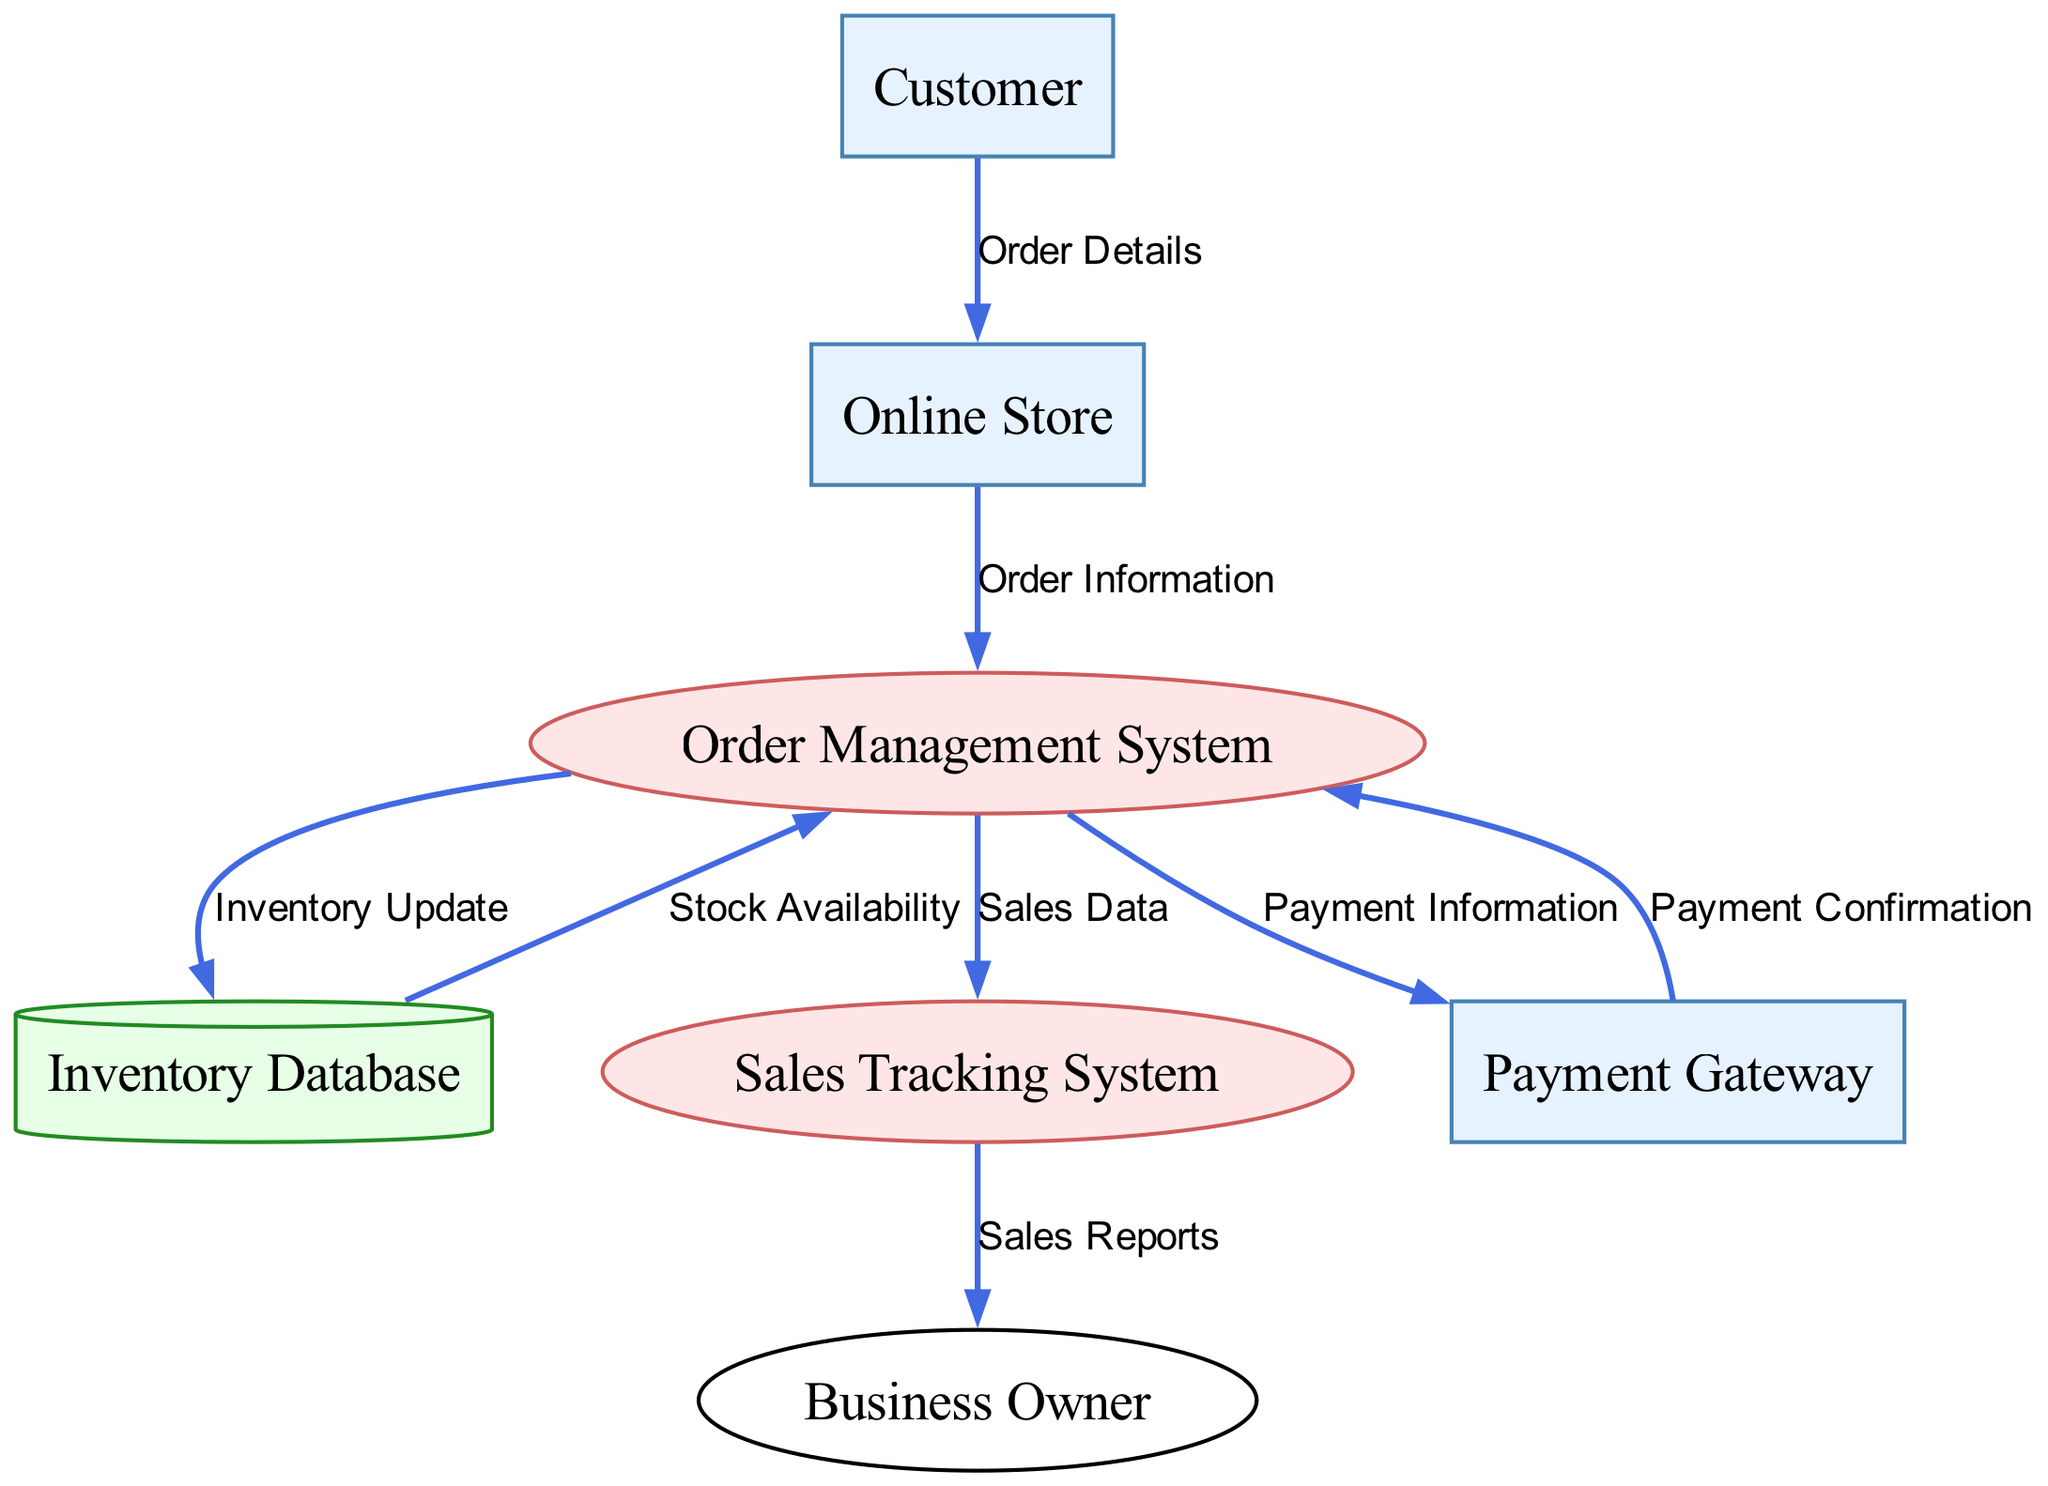What is the initial point of data flow in the diagram? The initial point of data flow is from the Customer, who provides Order Details to the Online Store. This can be identified as the first data flow shown in the diagram.
Answer: Customer How many processes are depicted in the diagram? The diagram contains three processes: the Order Management System and the Sales Tracking System. They play crucial roles in managing orders and sales; counting them gives us a total of three.
Answer: 2 Which entity receives Sales Data from the Order Management System? The Sales Tracking System receives Sales Data from the Order Management System. This relationship is indicated by one of the data flows in the diagram.
Answer: Sales Tracking System What type of entity is the Inventory Database? The Inventory Database is a data store, categorized as such based on its role in storing information about product stock levels, as illustrated in the diagram.
Answer: Data Store How many data flows originate from the Order Management System? There are four data flows originating from the Order Management System: one to the Inventory Database, one to the Sales Tracking System, one to the Payment Gateway, and one returning from the Payment Gateway. This counting reveals the dynamics involving the Order Management System.
Answer: 4 Which entity provides Payment Confirmation back to the Order Management System? The Payment Gateway provides Payment Confirmation back to the Order Management System. This flow is directed from the Payment Gateway to the Order Management System, indicating the response after processing the payment.
Answer: Payment Gateway What data does the Inventory Database send back to the Order Management System? The Inventory Database sends Stock Availability back to the Order Management System. This data flow highlights the feedback loop for maintaining inventory levels in response to order processing.
Answer: Stock Availability Who receives Sales Reports from the Sales Tracking System? The Business Owner receives Sales Reports from the Sales Tracking System. This detail indicates the output from the process used for tracking sales within the business.
Answer: Business Owner 